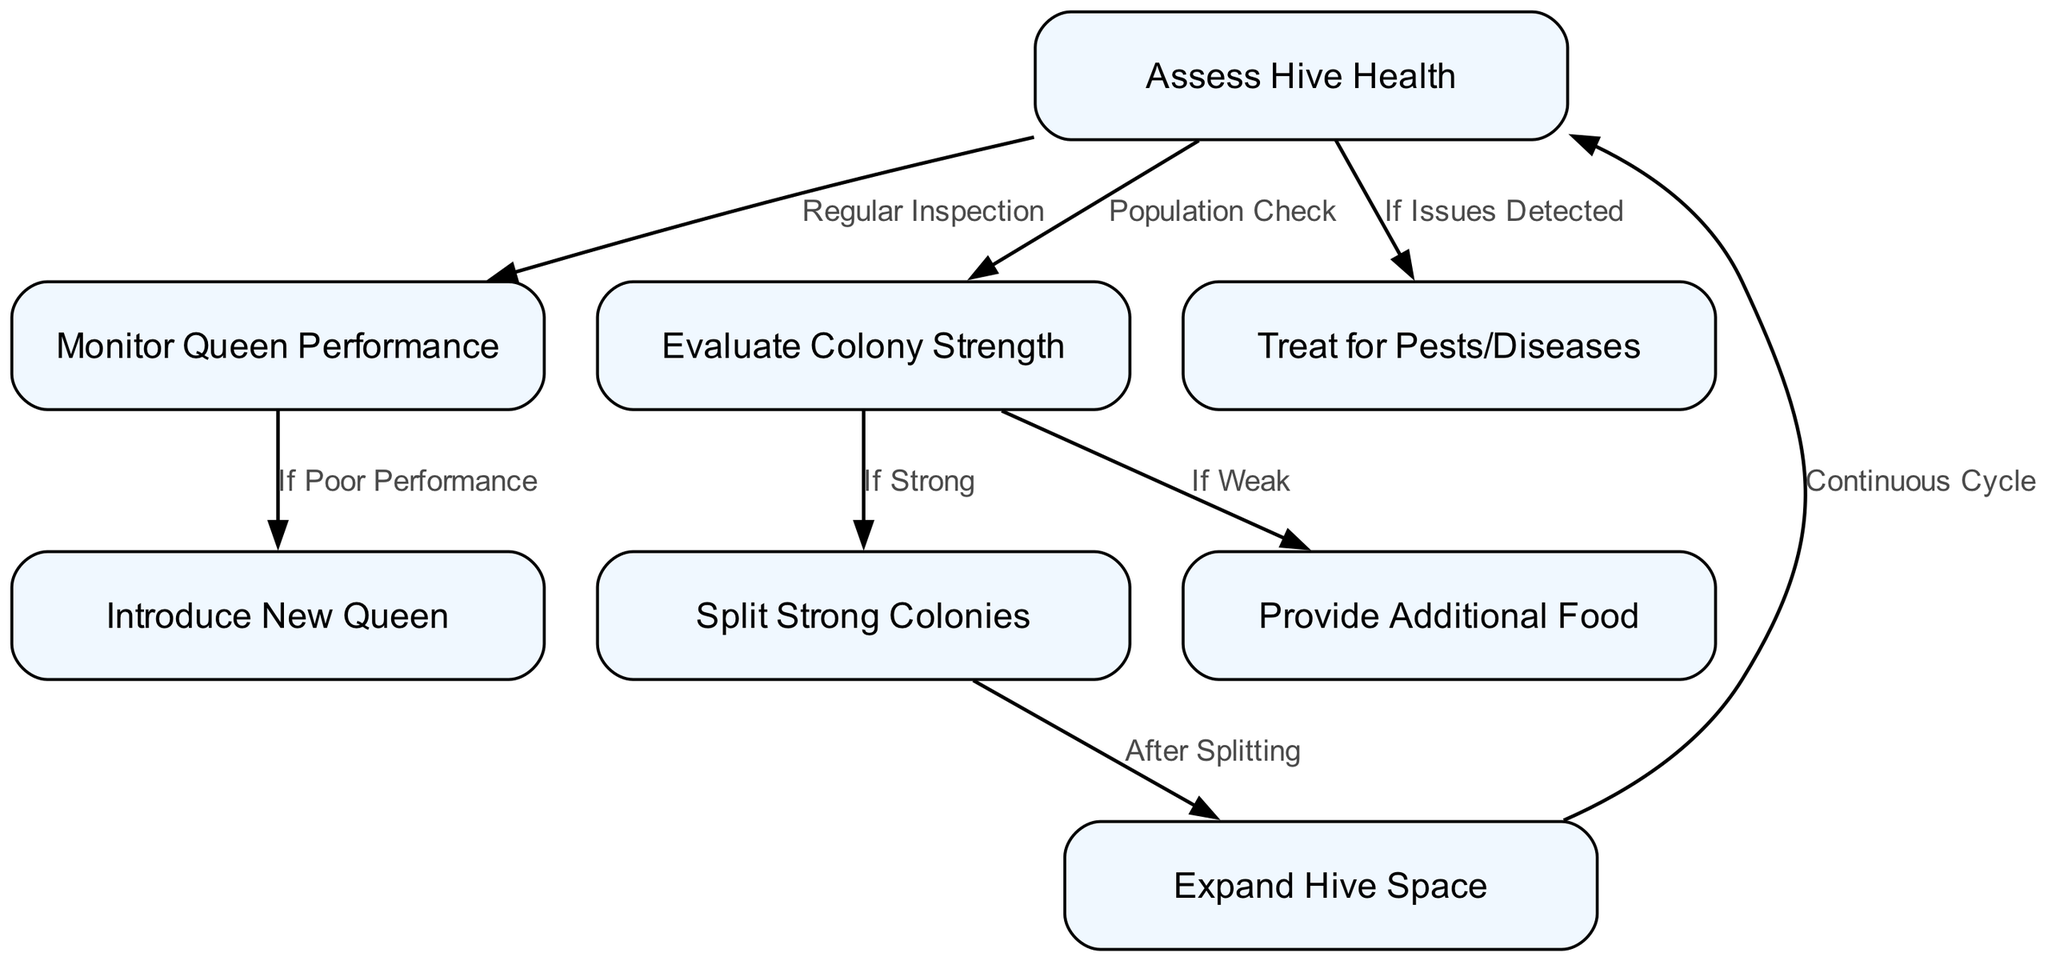What is the first step in the process? The first step in the process is "Assess Hive Health." This can be identified by looking at the top node in the flowchart, which is designated as the starting point for the processes involved in colony expansion and maintenance.
Answer: Assess Hive Health How many nodes are there in the diagram? To determine the number of nodes, simply count each unique entry listed in the "nodes" section of the data. There are a total of eight distinct nodes representing steps or actions in the beekeeping process.
Answer: 8 What action follows "Evaluate Colony Strength" if the colony is strong? If the colony is determined to be strong, the next action is to "Split Strong Colonies," as indicated by the edge that connects these two nodes in the flowchart.
Answer: Split Strong Colonies Under what condition would additional food be provided? Additional food is provided "If Weak," as specified by the edge that connects "Evaluate Colony Strength" to "Provide Additional Food." This indicates that a weak colony requires extra resources to support it.
Answer: If Weak What happens after splitting strong colonies? After splitting strong colonies, the next step is to "Expand Hive Space." This transition can be traced directly from the "Split Strong Colonies" node to the "Expand Hive Space" node in the flowchart.
Answer: Expand Hive Space How does the process cycle back to the beginning? The process cycles back to "Assess Hive Health" from "Expand Hive Space," creating a continuous loop in the management of colony health, signifying that after gaining more space, monitoring begins anew.
Answer: Continuous Cycle What is the action taken when queen performance is poor? When the queen performance is poor, the specified action is to "Introduce New Queen," which is clearly indicated as the follow-up action in the diagram after assessing queen performance.
Answer: Introduce New Queen What other conditions can lead to treatment for pests and diseases? Treatment for pests and diseases occurs "If Issues Detected," as denoted by the edge leading from "Assess Hive Health" to "Treat for Pests/Diseases." This suggests a proactive approach when problems are identified.
Answer: If Issues Detected 